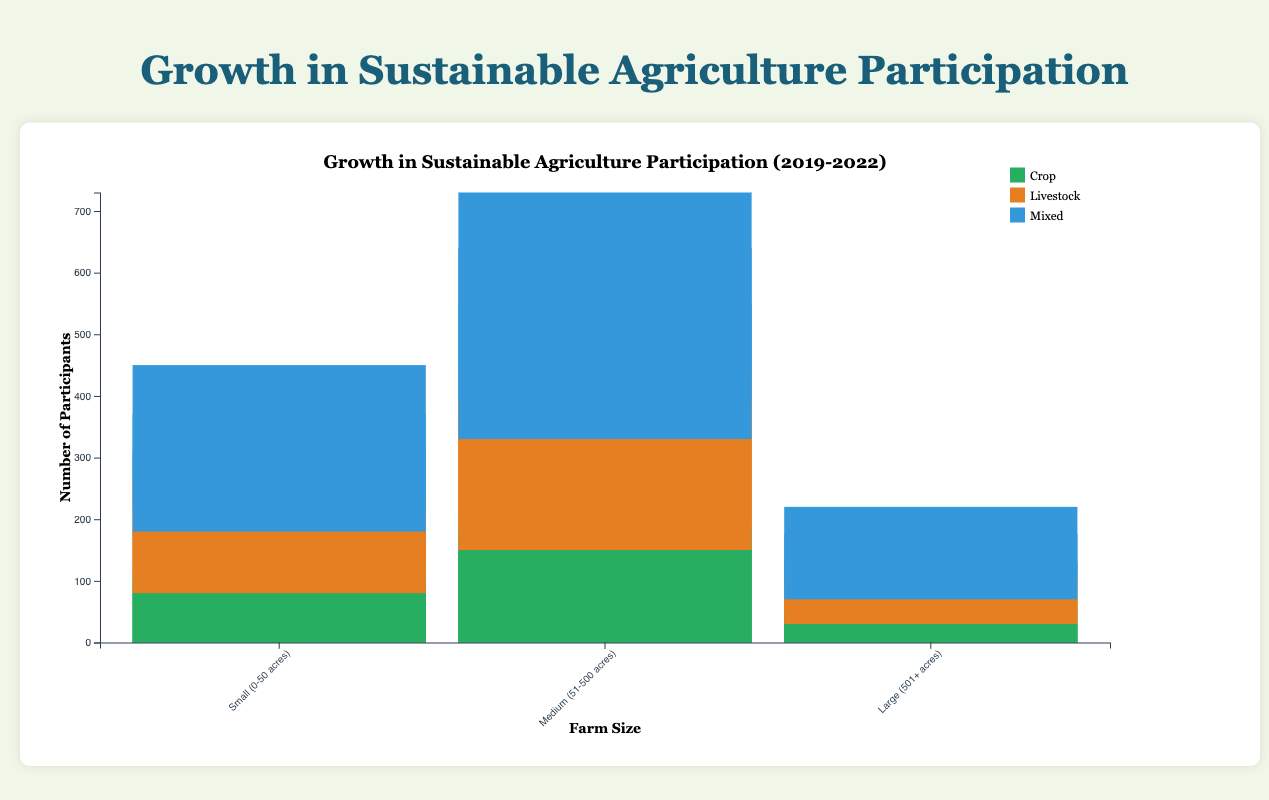What is the title of the chart? The title is located at the top of the chart and reads "Growth in Sustainable Agriculture Participation".
Answer: Growth in Sustainable Agriculture Participation What does the y-axis represent? The y-axis label reads "Number of Participants". This indicates that the y-axis displays the number of participants in sustainable agriculture programs.
Answer: Number of Participants Which farm size had the highest number of participants in 2022 for crop farming? Observing the bar heights for each farm size in the crop category for the year 2022, we see that the bar for "Medium (51-500 acres)" is the highest.
Answer: Medium (51-500 acres) How many participants were there in small farms (0-50 acres) for livestock farming in 2020? Looking at the small farms section under livestock type in 2020, we see the height of the corresponding bar indicates the number 100 participants.
Answer: 100 What was the total number of participants from large farms (501+ acres) in mixed farming over all the years combined? The numbers for large farms in mixed farming category across the years are 40, 55, 80, and 110. Summing these values: 40 + 55 + 80 + 110 = 285.
Answer: 285 Did small (0-50 acres) or medium (51-500 acres) farms have a higher percentage growth in crop farming from 2019 to 2022? For small farms, crop participation grew from 120 to 210, a growth of 90 (210-120). For medium farms, crop participation grew from 200 to 350, a growth of 150 (350-200). Calculating percentages: Small: (90/120)*100 ≈ 75%. Medium: (150/200)*100 ≈ 75%. So, both had an equal percentage growth.
Answer: Equal percentage growth Which type of farming showed the least participation growth in large farms from 2019 to 2022? For large farms, we check growths from 2019 to 2022. Crop: 50 to 140 (+90), Livestock: 30 to 90 (+60), Mixed: 40 to 110 (+70). Livestock showed the least growth of 60 participants.
Answer: Livestock How many more participants were there in medium-sized farms (51-500 acres) for mixed farming than for livestock farming in 2021? The bar height for medium farms in mixed farming in 2021 is 250, while for livestock it's 220. The difference is 250 - 220 = 30.
Answer: 30 What is the average number of participants in small farms for mixed farming over the years? The participant numbers for small farms in mixed farming are 100, 120, 150, and 190. Sum these values and divide by 4: (100 + 120 + 150 + 190) / 4 = 140.
Answer: 140 Which farm size and type had the most consistent increase in participation from 2019 to 2022? By examining each segment, medium-sized mixed farms had a progression of 180, 210, 250, and 300 participants. This shows a consistent increase with each year.
Answer: Medium-sized mixed farms 